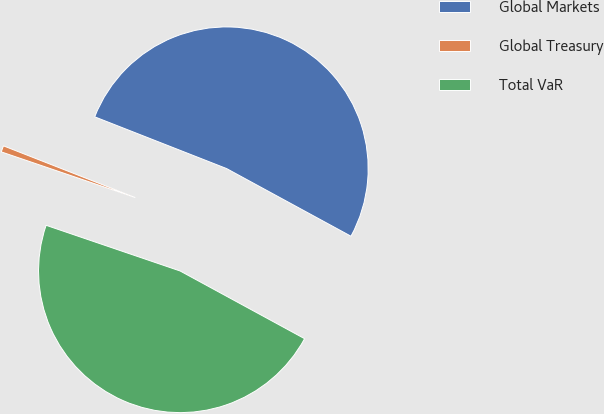<chart> <loc_0><loc_0><loc_500><loc_500><pie_chart><fcel>Global Markets<fcel>Global Treasury<fcel>Total VaR<nl><fcel>51.98%<fcel>0.72%<fcel>47.3%<nl></chart> 